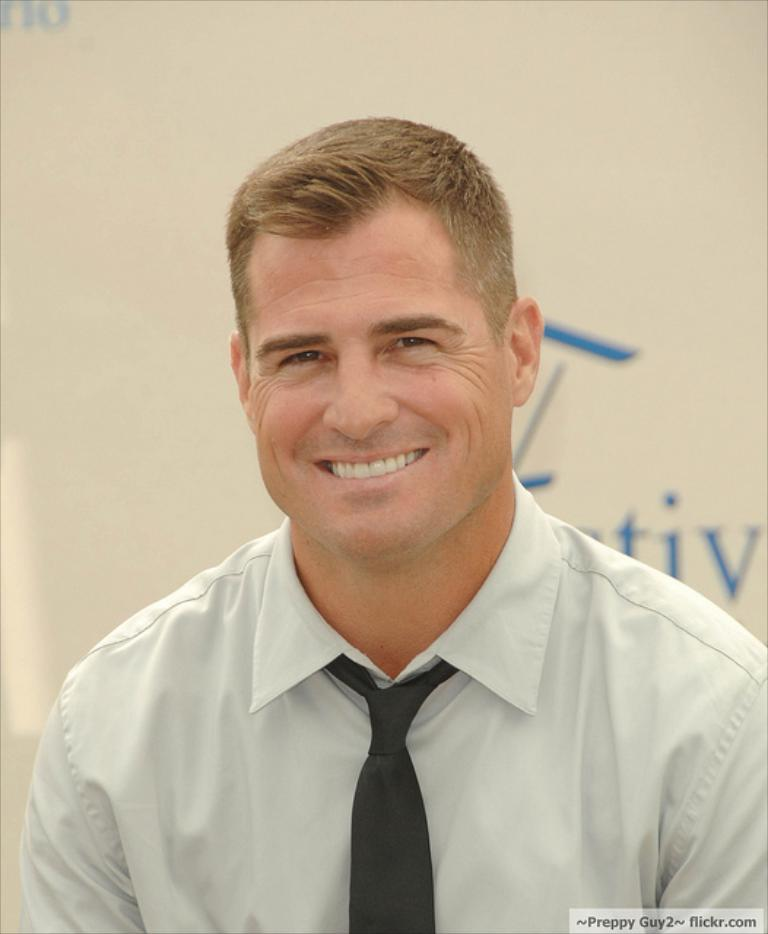Who is the main subject in the foreground of the image? There is a man in the foreground of the image. What is the man wearing? The man is wearing a white shirt and tie. What is the man's facial expression? The man is smiling. What can be seen in the background of the image? There is a board in the background of the image. What is written on the board? There is text on the board. What type of birds can be seen flying over the man's head in the image? There are no birds visible in the image. 